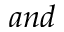Convert formula to latex. <formula><loc_0><loc_0><loc_500><loc_500>a n d</formula> 